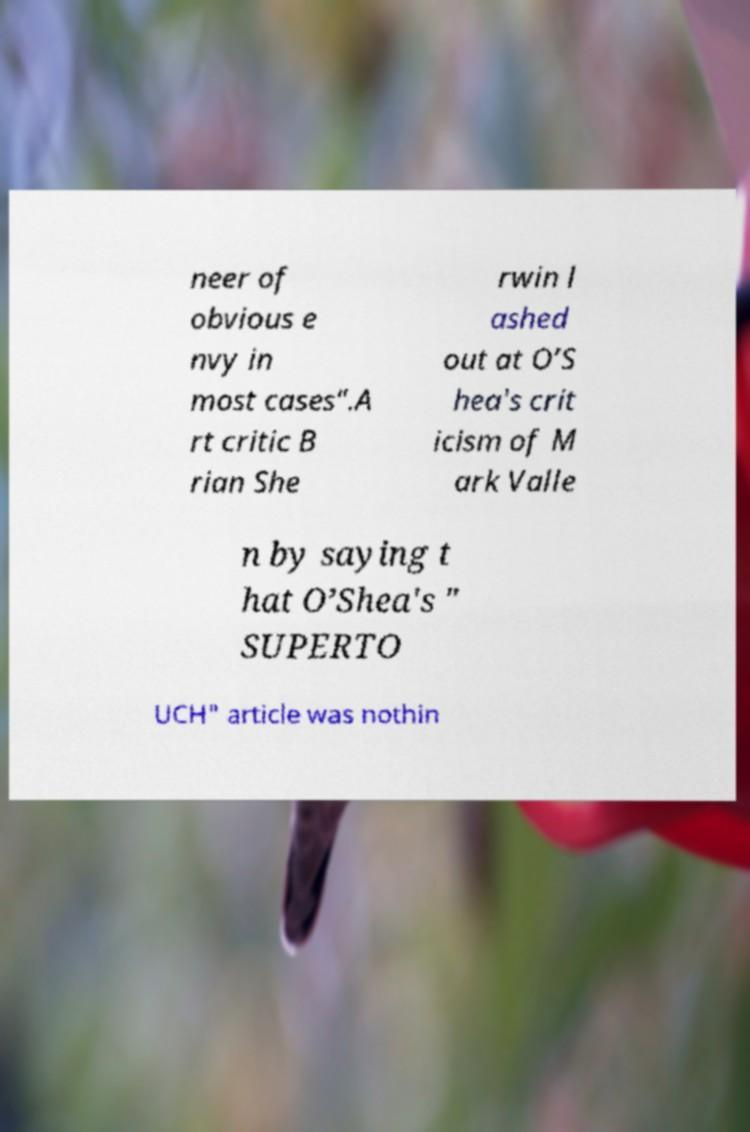Please identify and transcribe the text found in this image. neer of obvious e nvy in most cases".A rt critic B rian She rwin l ashed out at O’S hea's crit icism of M ark Valle n by saying t hat O’Shea's " SUPERTO UCH" article was nothin 